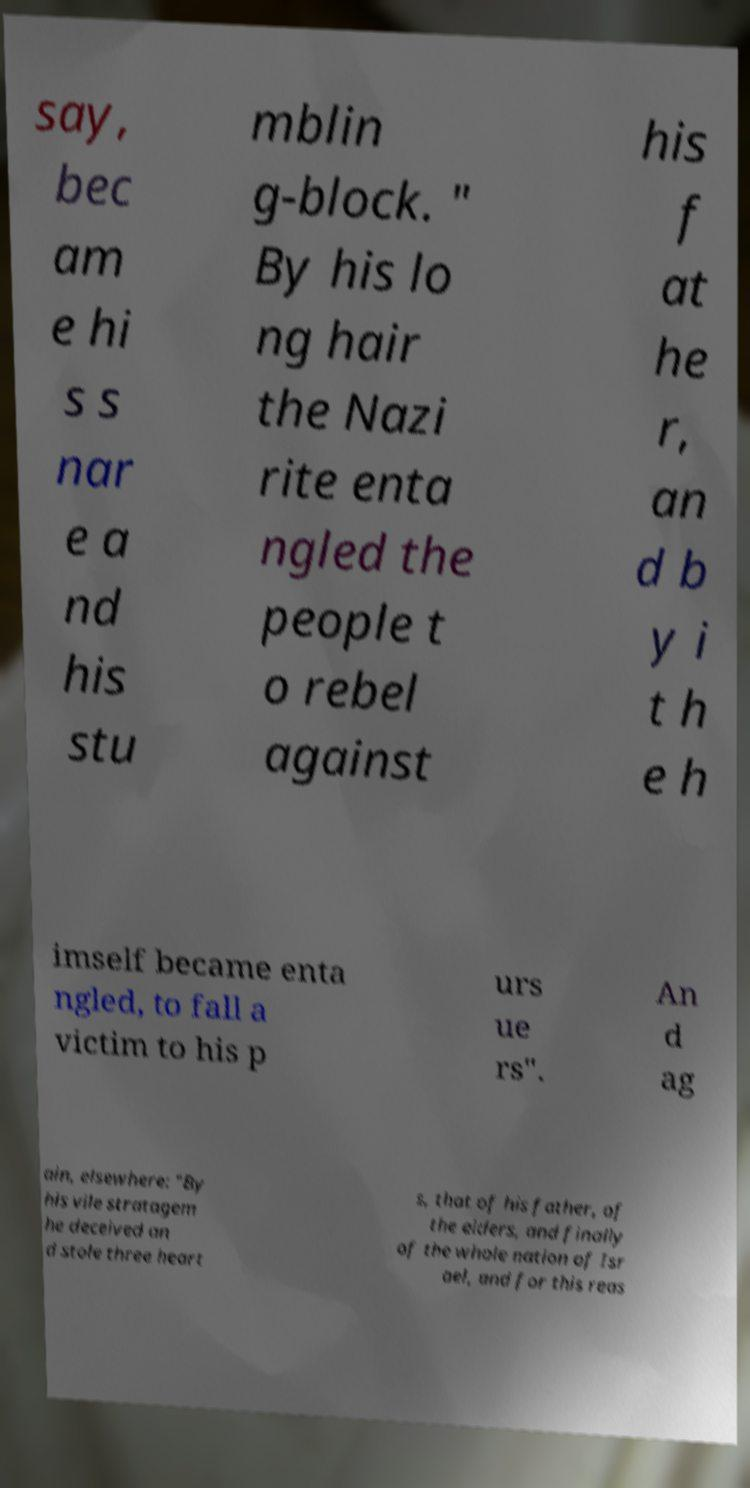What messages or text are displayed in this image? I need them in a readable, typed format. say, bec am e hi s s nar e a nd his stu mblin g-block. " By his lo ng hair the Nazi rite enta ngled the people t o rebel against his f at he r, an d b y i t h e h imself became enta ngled, to fall a victim to his p urs ue rs". An d ag ain, elsewhere: "By his vile stratagem he deceived an d stole three heart s, that of his father, of the elders, and finally of the whole nation of Isr ael, and for this reas 